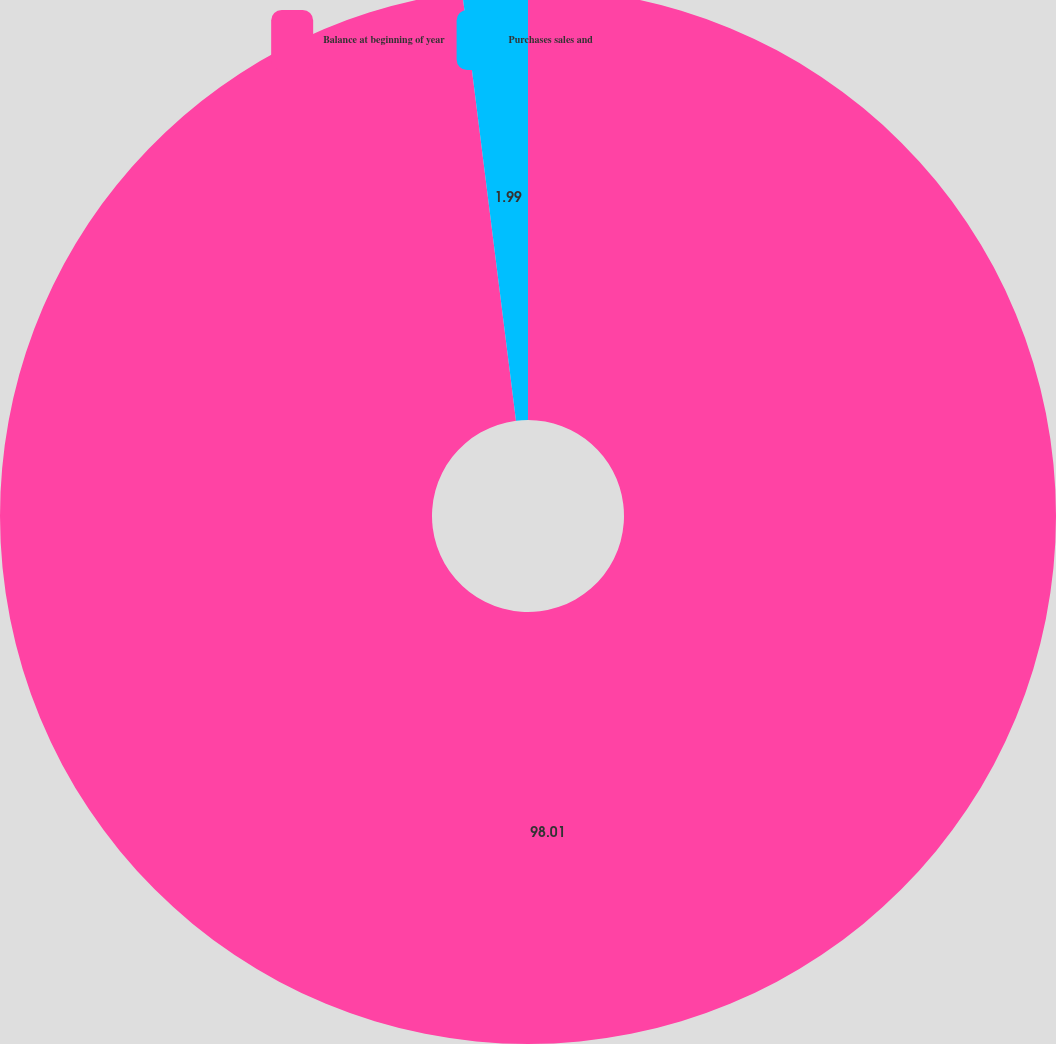<chart> <loc_0><loc_0><loc_500><loc_500><pie_chart><fcel>Balance at beginning of year<fcel>Purchases sales and<nl><fcel>98.01%<fcel>1.99%<nl></chart> 